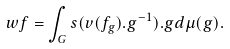<formula> <loc_0><loc_0><loc_500><loc_500>w f = \int _ { G } s ( v ( f _ { g } ) . g ^ { - 1 } ) . g d \mu ( g ) .</formula> 